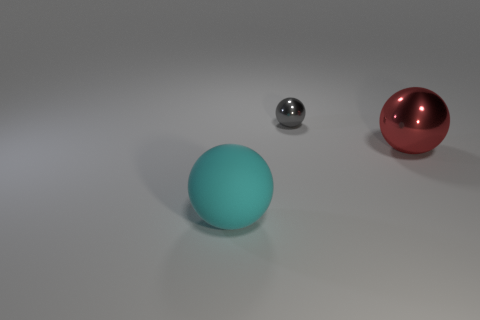Subtract all red spheres. How many spheres are left? 2 Subtract all red balls. How many balls are left? 2 Subtract 2 balls. How many balls are left? 1 Subtract all green balls. Subtract all red cubes. How many balls are left? 3 Subtract all gray cubes. How many cyan spheres are left? 1 Subtract all large red things. Subtract all red objects. How many objects are left? 1 Add 3 cyan things. How many cyan things are left? 4 Add 3 metal spheres. How many metal spheres exist? 5 Add 1 balls. How many objects exist? 4 Subtract 1 red spheres. How many objects are left? 2 